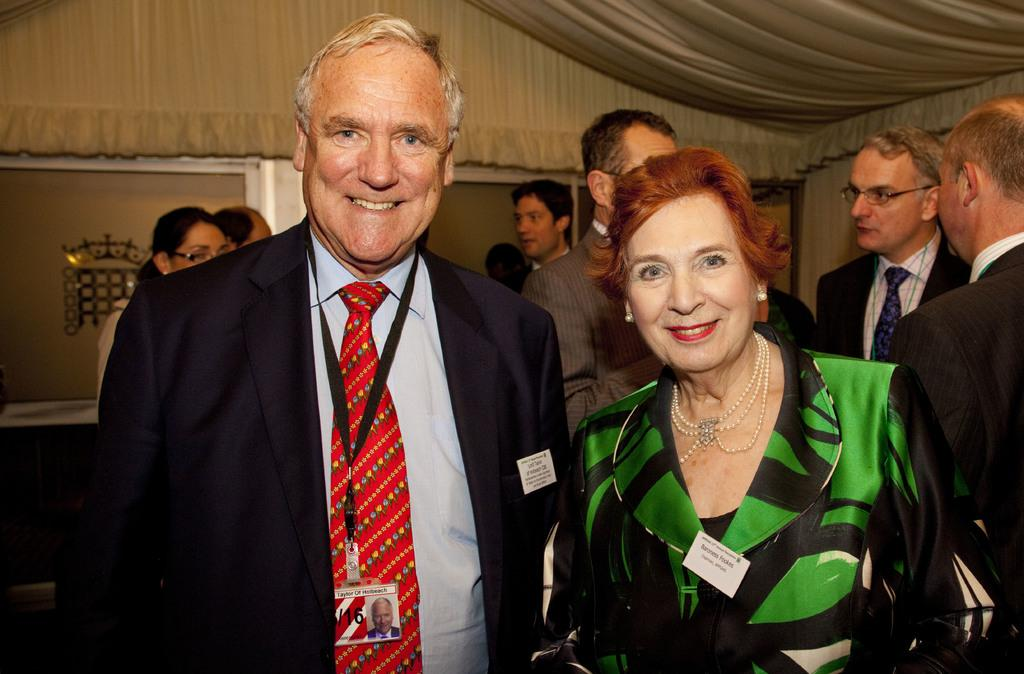What is the relationship between the man and the woman in the image? The provided facts do not give information about the relationship between the man and the woman. What can be seen in the background of the image? In the background of the image, there are multiple persons standing near a wall and door. What type of clothing is visible in the image? Clothes are visible at the top of the image. What level of the building is the man standing on in the image? The provided facts do not give information about the level of the building or the man's position relative to it. Is there a market visible in the image? There is no mention of a market in the provided facts. 